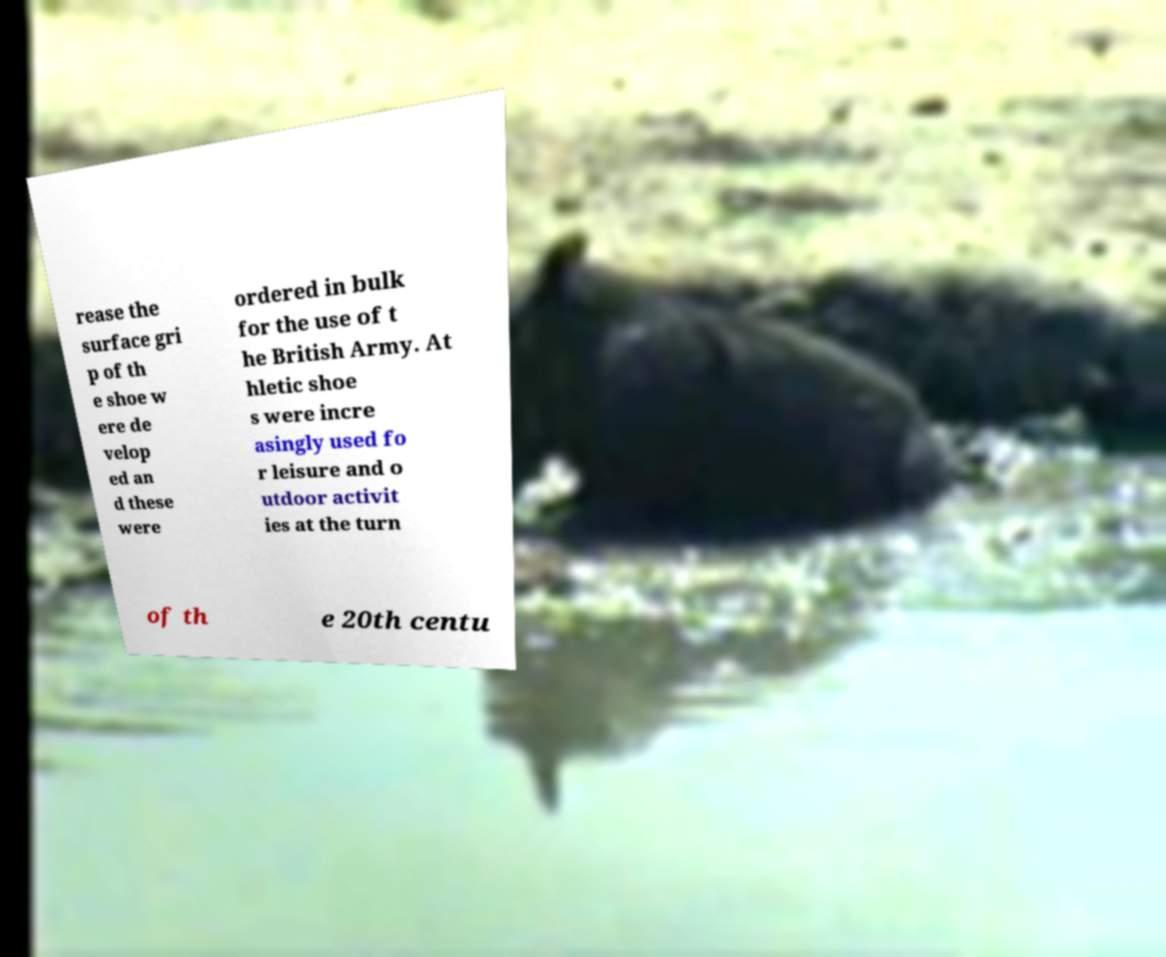For documentation purposes, I need the text within this image transcribed. Could you provide that? rease the surface gri p of th e shoe w ere de velop ed an d these were ordered in bulk for the use of t he British Army. At hletic shoe s were incre asingly used fo r leisure and o utdoor activit ies at the turn of th e 20th centu 